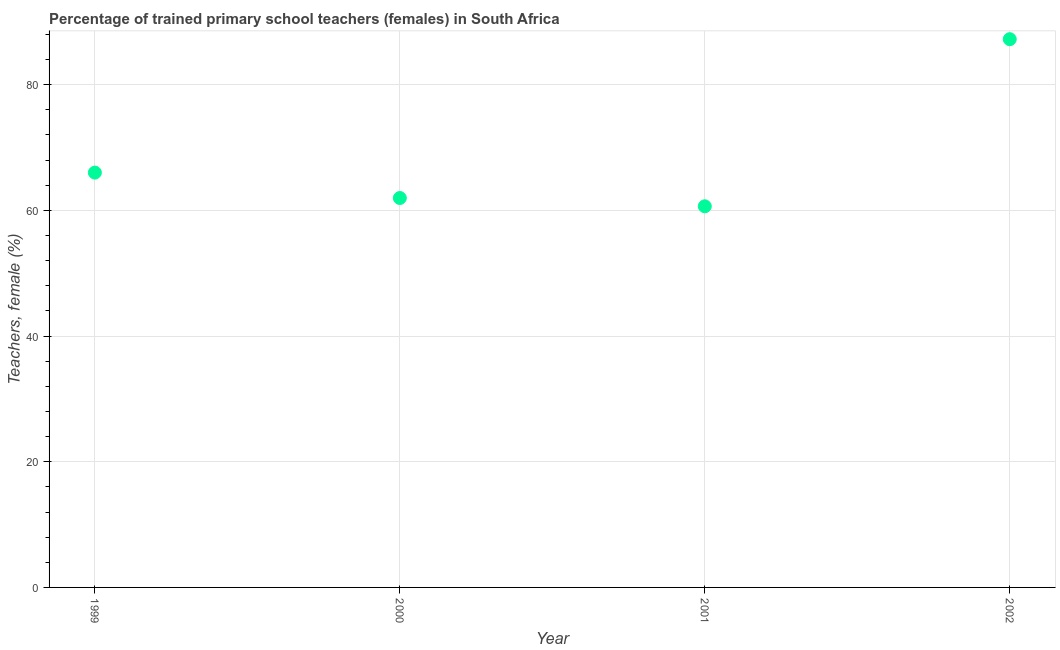What is the percentage of trained female teachers in 2000?
Make the answer very short. 61.96. Across all years, what is the maximum percentage of trained female teachers?
Offer a very short reply. 87.23. Across all years, what is the minimum percentage of trained female teachers?
Give a very brief answer. 60.64. In which year was the percentage of trained female teachers maximum?
Keep it short and to the point. 2002. What is the sum of the percentage of trained female teachers?
Provide a short and direct response. 275.83. What is the difference between the percentage of trained female teachers in 2000 and 2001?
Ensure brevity in your answer.  1.32. What is the average percentage of trained female teachers per year?
Ensure brevity in your answer.  68.96. What is the median percentage of trained female teachers?
Keep it short and to the point. 63.98. In how many years, is the percentage of trained female teachers greater than 72 %?
Give a very brief answer. 1. Do a majority of the years between 2000 and 2002 (inclusive) have percentage of trained female teachers greater than 24 %?
Ensure brevity in your answer.  Yes. What is the ratio of the percentage of trained female teachers in 1999 to that in 2001?
Offer a very short reply. 1.09. Is the difference between the percentage of trained female teachers in 2000 and 2002 greater than the difference between any two years?
Make the answer very short. No. What is the difference between the highest and the second highest percentage of trained female teachers?
Offer a very short reply. 21.23. What is the difference between the highest and the lowest percentage of trained female teachers?
Offer a very short reply. 26.59. In how many years, is the percentage of trained female teachers greater than the average percentage of trained female teachers taken over all years?
Your response must be concise. 1. Does the percentage of trained female teachers monotonically increase over the years?
Your answer should be compact. No. Are the values on the major ticks of Y-axis written in scientific E-notation?
Offer a terse response. No. Does the graph contain any zero values?
Give a very brief answer. No. What is the title of the graph?
Your response must be concise. Percentage of trained primary school teachers (females) in South Africa. What is the label or title of the X-axis?
Offer a very short reply. Year. What is the label or title of the Y-axis?
Your answer should be very brief. Teachers, female (%). What is the Teachers, female (%) in 1999?
Make the answer very short. 66. What is the Teachers, female (%) in 2000?
Ensure brevity in your answer.  61.96. What is the Teachers, female (%) in 2001?
Keep it short and to the point. 60.64. What is the Teachers, female (%) in 2002?
Your answer should be compact. 87.23. What is the difference between the Teachers, female (%) in 1999 and 2000?
Your answer should be compact. 4.04. What is the difference between the Teachers, female (%) in 1999 and 2001?
Keep it short and to the point. 5.36. What is the difference between the Teachers, female (%) in 1999 and 2002?
Your response must be concise. -21.23. What is the difference between the Teachers, female (%) in 2000 and 2001?
Your answer should be compact. 1.32. What is the difference between the Teachers, female (%) in 2000 and 2002?
Your response must be concise. -25.27. What is the difference between the Teachers, female (%) in 2001 and 2002?
Your response must be concise. -26.59. What is the ratio of the Teachers, female (%) in 1999 to that in 2000?
Provide a short and direct response. 1.06. What is the ratio of the Teachers, female (%) in 1999 to that in 2001?
Provide a succinct answer. 1.09. What is the ratio of the Teachers, female (%) in 1999 to that in 2002?
Ensure brevity in your answer.  0.76. What is the ratio of the Teachers, female (%) in 2000 to that in 2001?
Make the answer very short. 1.02. What is the ratio of the Teachers, female (%) in 2000 to that in 2002?
Your answer should be very brief. 0.71. What is the ratio of the Teachers, female (%) in 2001 to that in 2002?
Give a very brief answer. 0.69. 